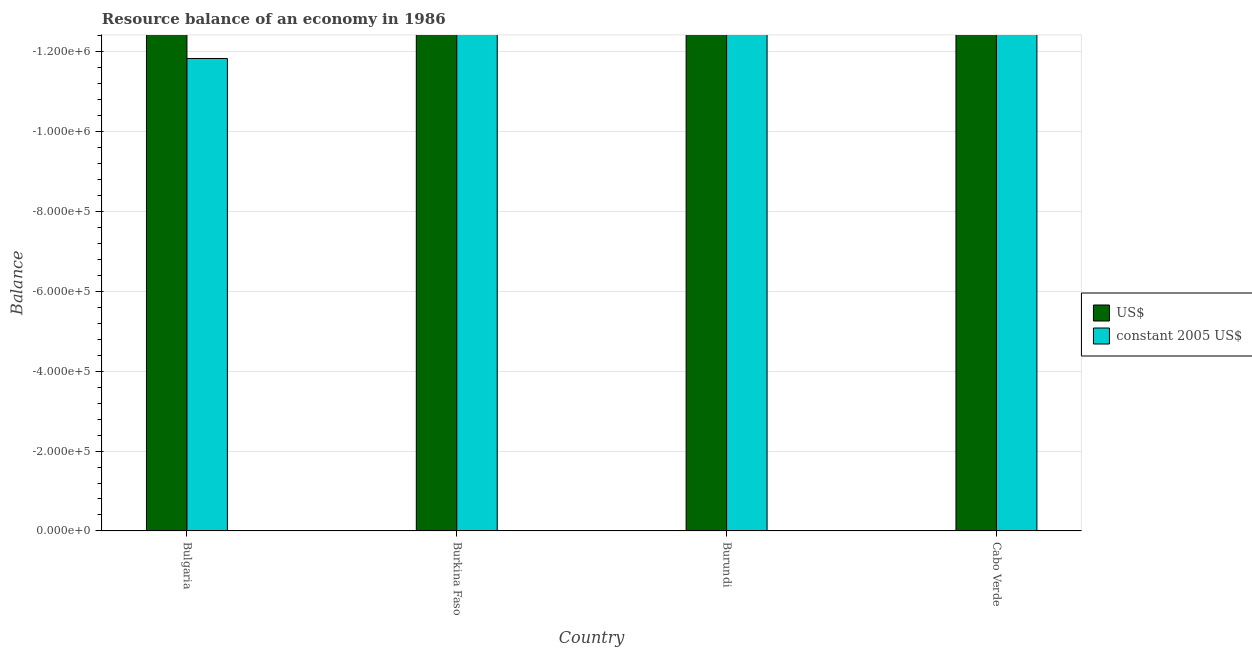How many bars are there on the 2nd tick from the left?
Your answer should be compact. 0. How many bars are there on the 2nd tick from the right?
Keep it short and to the point. 0. In how many cases, is the number of bars for a given country not equal to the number of legend labels?
Ensure brevity in your answer.  4. What is the total resource balance in constant us$ in the graph?
Offer a terse response. 0. What is the difference between the resource balance in us$ in Burundi and the resource balance in constant us$ in Cabo Verde?
Give a very brief answer. 0. In how many countries, is the resource balance in constant us$ greater than -840000 units?
Offer a terse response. 0. In how many countries, is the resource balance in us$ greater than the average resource balance in us$ taken over all countries?
Give a very brief answer. 0. Are all the bars in the graph horizontal?
Your answer should be very brief. No. How many countries are there in the graph?
Offer a very short reply. 4. What is the difference between two consecutive major ticks on the Y-axis?
Provide a short and direct response. 2.00e+05. Are the values on the major ticks of Y-axis written in scientific E-notation?
Keep it short and to the point. Yes. What is the title of the graph?
Provide a succinct answer. Resource balance of an economy in 1986. What is the label or title of the Y-axis?
Provide a succinct answer. Balance. What is the Balance of US$ in Burkina Faso?
Offer a terse response. 0. What is the Balance in US$ in Burundi?
Your answer should be compact. 0. What is the Balance of constant 2005 US$ in Cabo Verde?
Keep it short and to the point. 0. What is the total Balance of constant 2005 US$ in the graph?
Provide a short and direct response. 0. What is the average Balance of US$ per country?
Provide a succinct answer. 0. What is the average Balance in constant 2005 US$ per country?
Your answer should be compact. 0. 